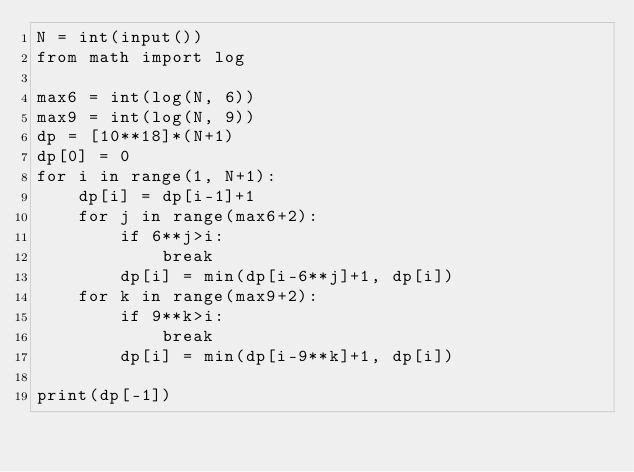<code> <loc_0><loc_0><loc_500><loc_500><_Python_>N = int(input())
from math import log

max6 = int(log(N, 6))
max9 = int(log(N, 9))
dp = [10**18]*(N+1)
dp[0] = 0
for i in range(1, N+1):
    dp[i] = dp[i-1]+1
    for j in range(max6+2):
        if 6**j>i:
            break
        dp[i] = min(dp[i-6**j]+1, dp[i])
    for k in range(max9+2):
        if 9**k>i:
            break
        dp[i] = min(dp[i-9**k]+1, dp[i])

print(dp[-1])</code> 